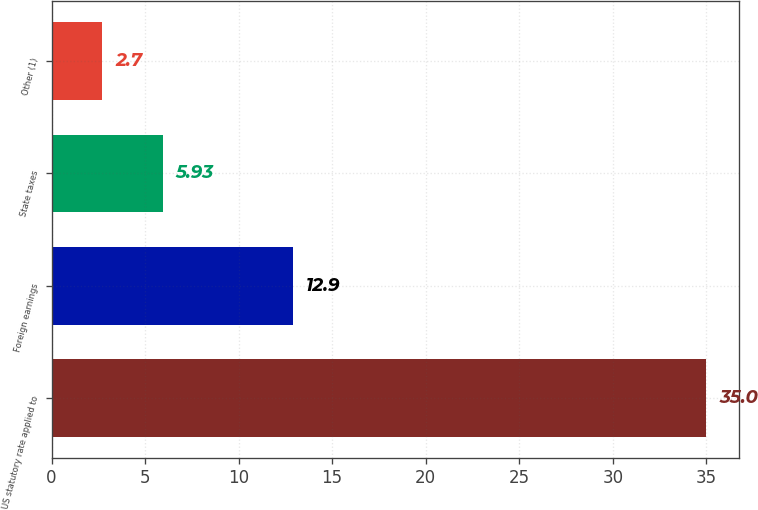<chart> <loc_0><loc_0><loc_500><loc_500><bar_chart><fcel>US statutory rate applied to<fcel>Foreign earnings<fcel>State taxes<fcel>Other (1)<nl><fcel>35<fcel>12.9<fcel>5.93<fcel>2.7<nl></chart> 